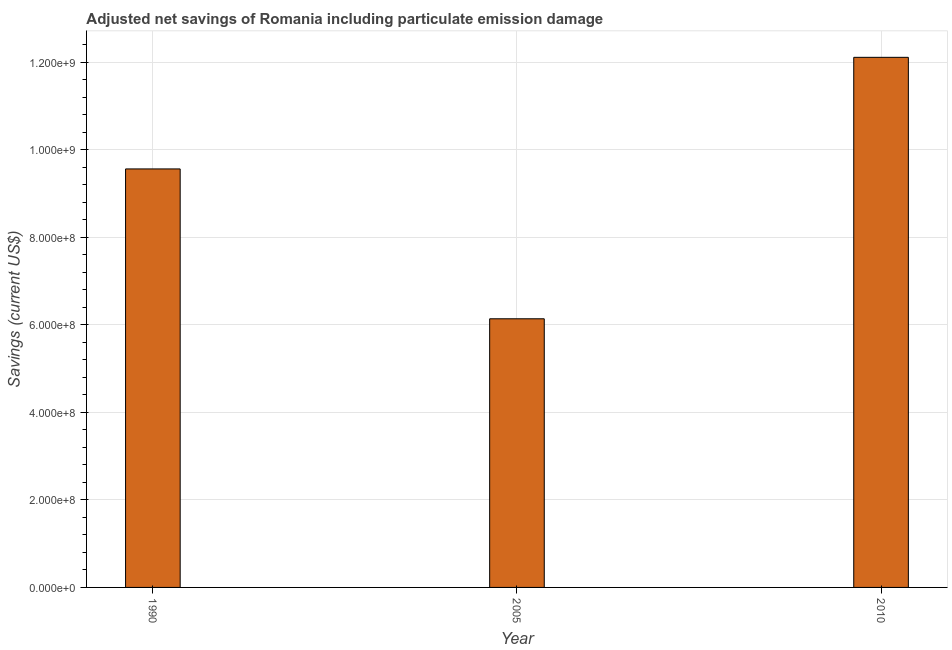Does the graph contain any zero values?
Offer a very short reply. No. What is the title of the graph?
Make the answer very short. Adjusted net savings of Romania including particulate emission damage. What is the label or title of the Y-axis?
Make the answer very short. Savings (current US$). What is the adjusted net savings in 1990?
Offer a very short reply. 9.56e+08. Across all years, what is the maximum adjusted net savings?
Keep it short and to the point. 1.21e+09. Across all years, what is the minimum adjusted net savings?
Make the answer very short. 6.14e+08. In which year was the adjusted net savings maximum?
Keep it short and to the point. 2010. What is the sum of the adjusted net savings?
Offer a terse response. 2.78e+09. What is the difference between the adjusted net savings in 1990 and 2005?
Your answer should be compact. 3.42e+08. What is the average adjusted net savings per year?
Keep it short and to the point. 9.27e+08. What is the median adjusted net savings?
Ensure brevity in your answer.  9.56e+08. Do a majority of the years between 1990 and 2005 (inclusive) have adjusted net savings greater than 320000000 US$?
Ensure brevity in your answer.  Yes. What is the ratio of the adjusted net savings in 2005 to that in 2010?
Offer a terse response. 0.51. What is the difference between the highest and the second highest adjusted net savings?
Ensure brevity in your answer.  2.55e+08. What is the difference between the highest and the lowest adjusted net savings?
Keep it short and to the point. 5.97e+08. In how many years, is the adjusted net savings greater than the average adjusted net savings taken over all years?
Give a very brief answer. 2. What is the difference between two consecutive major ticks on the Y-axis?
Provide a succinct answer. 2.00e+08. What is the Savings (current US$) of 1990?
Provide a succinct answer. 9.56e+08. What is the Savings (current US$) of 2005?
Make the answer very short. 6.14e+08. What is the Savings (current US$) in 2010?
Give a very brief answer. 1.21e+09. What is the difference between the Savings (current US$) in 1990 and 2005?
Give a very brief answer. 3.42e+08. What is the difference between the Savings (current US$) in 1990 and 2010?
Offer a very short reply. -2.55e+08. What is the difference between the Savings (current US$) in 2005 and 2010?
Give a very brief answer. -5.97e+08. What is the ratio of the Savings (current US$) in 1990 to that in 2005?
Make the answer very short. 1.56. What is the ratio of the Savings (current US$) in 1990 to that in 2010?
Provide a short and direct response. 0.79. What is the ratio of the Savings (current US$) in 2005 to that in 2010?
Provide a short and direct response. 0.51. 